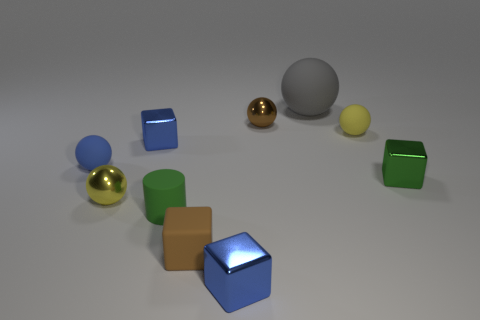Is there a small metal ball left of the tiny blue shiny cube that is behind the green shiny block?
Make the answer very short. Yes. There is a small yellow rubber thing; how many objects are in front of it?
Offer a terse response. 7. What number of other things are there of the same color as the big ball?
Make the answer very short. 0. Is the number of yellow rubber things that are behind the big gray matte object less than the number of small rubber spheres that are left of the green block?
Offer a very short reply. Yes. What number of things are tiny objects that are on the right side of the gray sphere or blue shiny things?
Ensure brevity in your answer.  4. There is a brown metal sphere; is it the same size as the brown object in front of the small brown ball?
Ensure brevity in your answer.  Yes. The yellow shiny object that is the same shape as the brown metallic thing is what size?
Your answer should be very brief. Small. How many rubber objects are on the left side of the tiny blue block that is right of the green thing left of the large rubber thing?
Make the answer very short. 3. What number of blocks are big green objects or gray rubber things?
Your response must be concise. 0. What color is the rubber object that is behind the small metal thing behind the tiny yellow sphere to the right of the brown sphere?
Provide a short and direct response. Gray. 